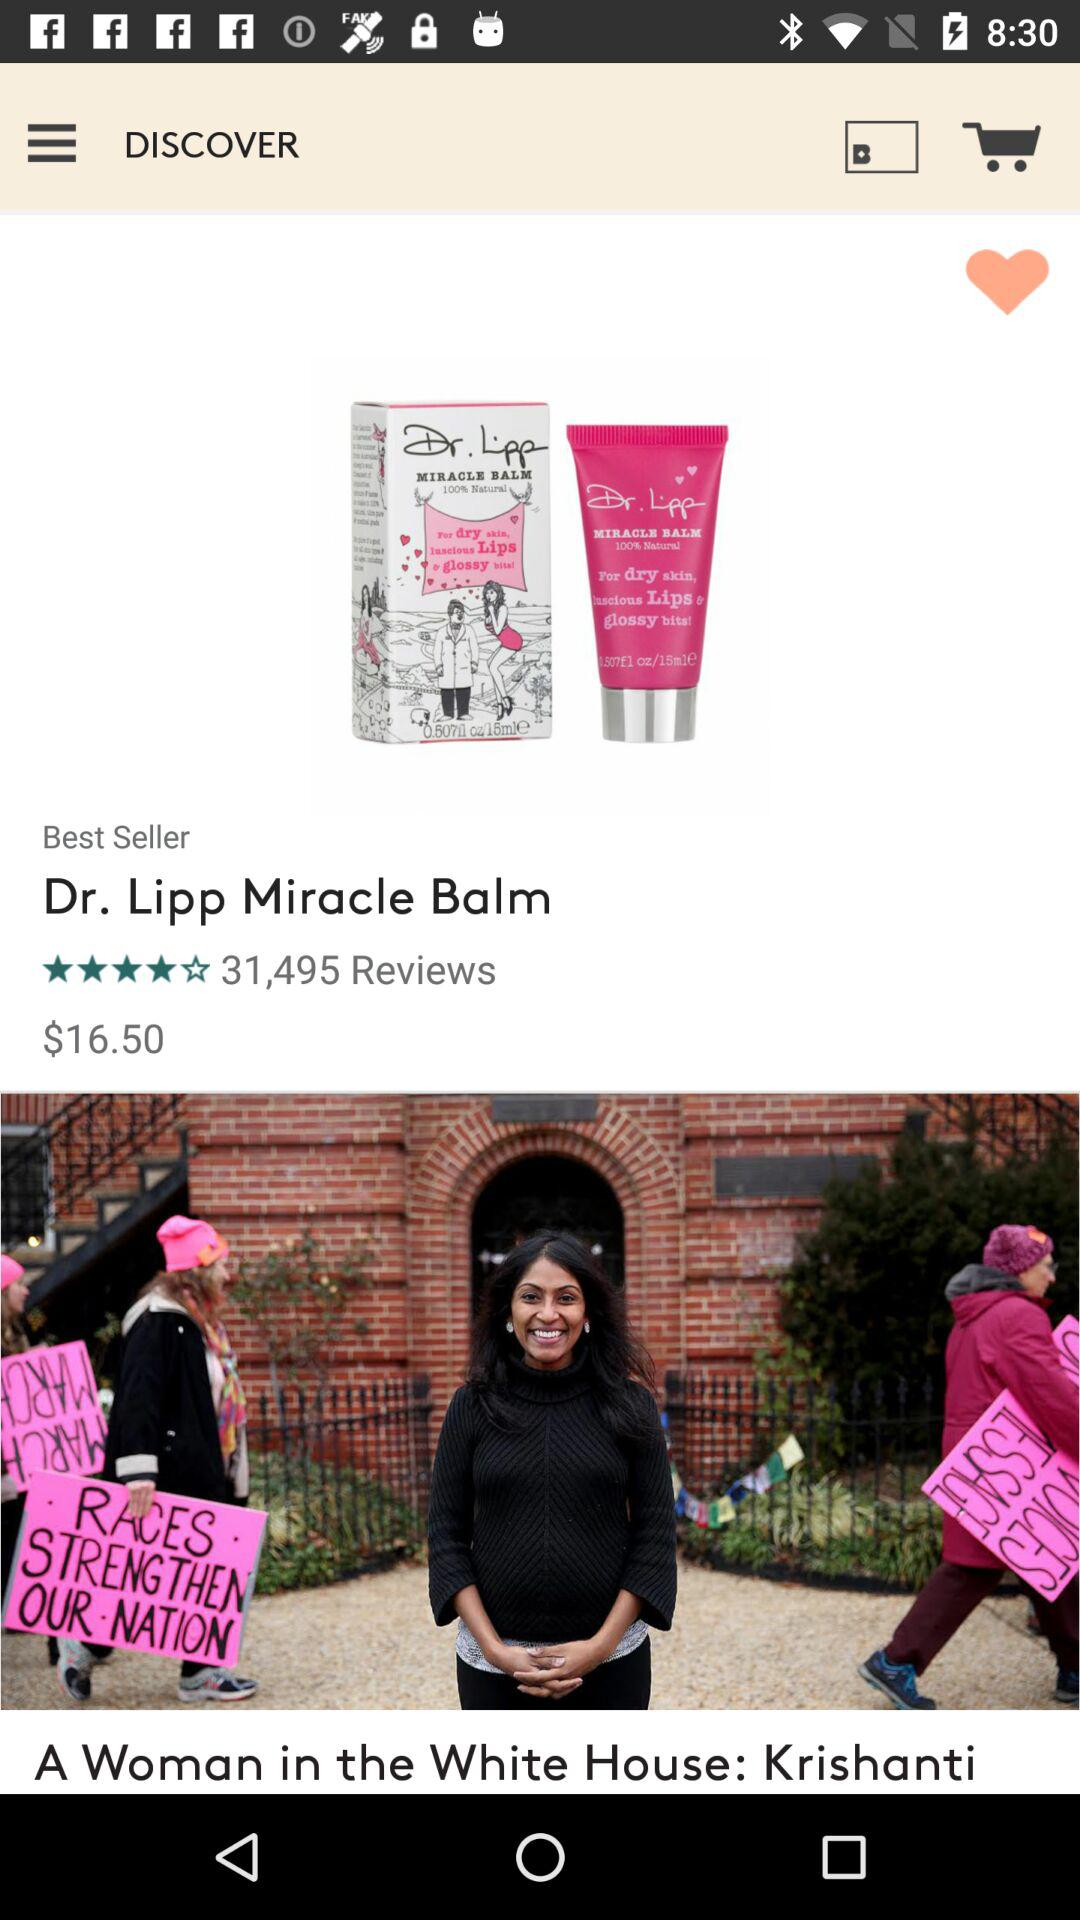What is the price of Dr. Lipp Miracle Balm? The price is $16.50. 